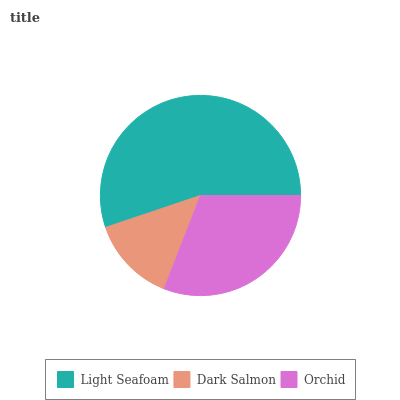Is Dark Salmon the minimum?
Answer yes or no. Yes. Is Light Seafoam the maximum?
Answer yes or no. Yes. Is Orchid the minimum?
Answer yes or no. No. Is Orchid the maximum?
Answer yes or no. No. Is Orchid greater than Dark Salmon?
Answer yes or no. Yes. Is Dark Salmon less than Orchid?
Answer yes or no. Yes. Is Dark Salmon greater than Orchid?
Answer yes or no. No. Is Orchid less than Dark Salmon?
Answer yes or no. No. Is Orchid the high median?
Answer yes or no. Yes. Is Orchid the low median?
Answer yes or no. Yes. Is Light Seafoam the high median?
Answer yes or no. No. Is Light Seafoam the low median?
Answer yes or no. No. 